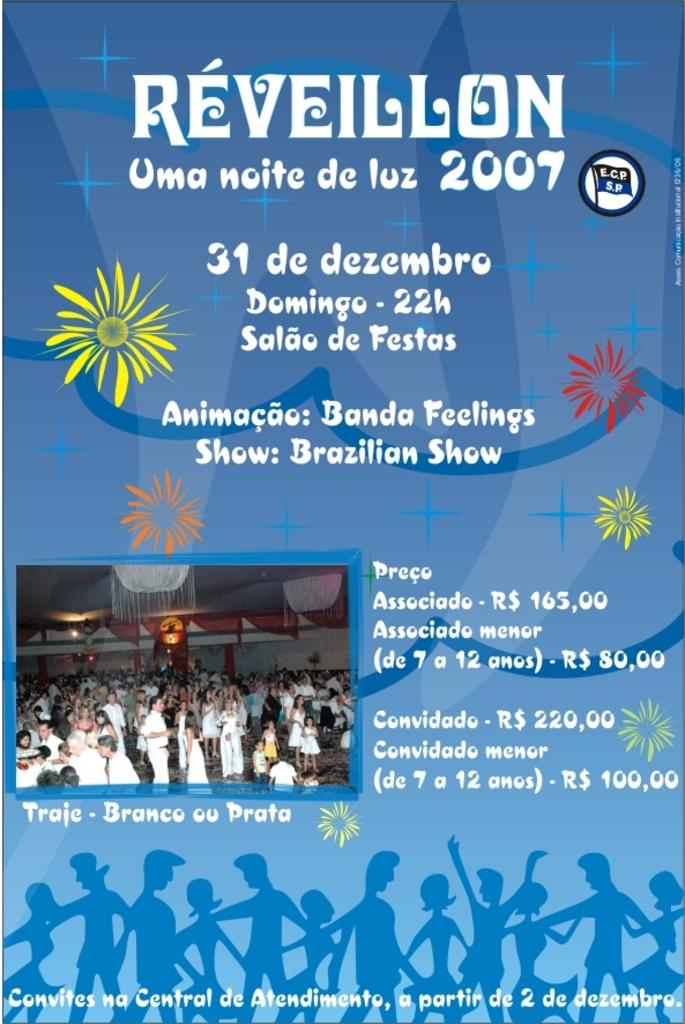What year this did take place?
Your answer should be very brief. 2007. 